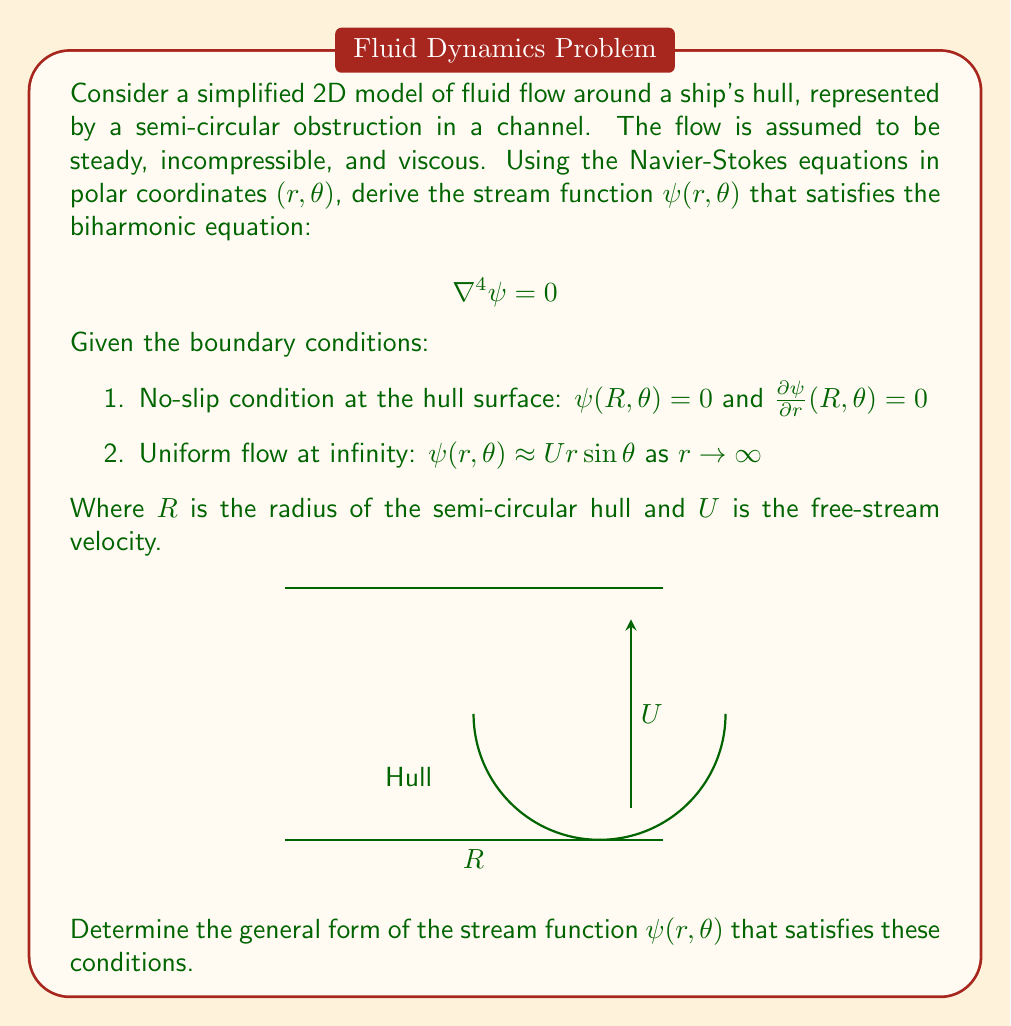Could you help me with this problem? To solve this problem, we'll follow these steps:

1) The general solution to the biharmonic equation in polar coordinates is:

   $$\psi(r,\theta) = (Ar + Br^3 + \frac{C}{r} + Dr\ln r)\sin\theta$$

   Where $A$, $B$, $C$, and $D$ are constants to be determined.

2) Apply the boundary condition at infinity:
   As $r \to \infty$, $\psi(r,\theta) \approx Ur\sin\theta$
   This implies $A = U$ and $B = D = 0$

3) Our stream function now becomes:

   $$\psi(r,\theta) = (Ur + \frac{C}{r})\sin\theta$$

4) Apply the no-slip conditions at $r = R$:

   a) $\psi(R,\theta) = 0$:
      $$(UR + \frac{C}{R})\sin\theta = 0$$
      This implies: $C = -UR^2$

   b) $\frac{\partial\psi}{\partial r}(R,\theta) = 0$:
      $$\frac{\partial}{\partial r}(Ur - \frac{UR^2}{r})\sin\theta = 0$$
      $$(U + \frac{UR^2}{r^2})\sin\theta = 0$$
      This is satisfied when $r = R$, confirming our solution.

5) Therefore, the final form of the stream function is:

   $$\psi(r,\theta) = U(r - \frac{R^2}{r})\sin\theta$$

This stream function satisfies the biharmonic equation and all given boundary conditions, providing a simplified model of the fluid flow around the ship's hull.
Answer: $$\psi(r,\theta) = U(r - \frac{R^2}{r})\sin\theta$$ 